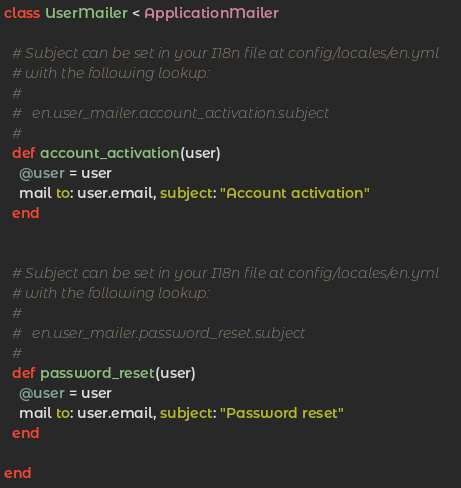<code> <loc_0><loc_0><loc_500><loc_500><_Ruby_>class UserMailer < ApplicationMailer

  # Subject can be set in your I18n file at config/locales/en.yml
  # with the following lookup:
  #
  #   en.user_mailer.account_activation.subject
  #
  def account_activation(user)
    @user = user
    mail to: user.email, subject: "Account activation"
  end


  # Subject can be set in your I18n file at config/locales/en.yml
  # with the following lookup:
  #
  #   en.user_mailer.password_reset.subject
  #
  def password_reset(user)
	@user = user
	mail to: user.email, subject: "Password reset"
  end
  
end
</code> 